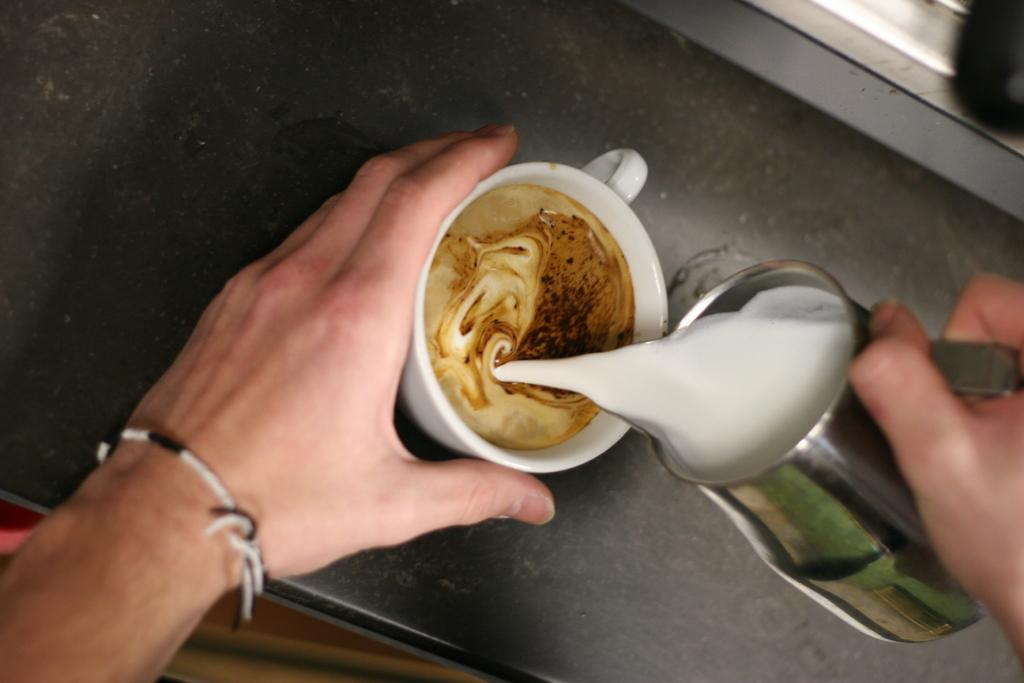What is being held by the person's hand in the image? There is a person's hand holding cups in the image. Can you describe the cups being held? Unfortunately, the image does not provide enough detail to describe the cups being held. What might the person be doing with the cups? The person might be preparing to serve drinks or organizing the cups. What type of work or industry is being depicted in the image? The image does not depict any specific work or industry; it only shows a person's hand holding cups. What room is the person in while holding the cups? The image does not provide enough context to determine the room in which the person is located. 